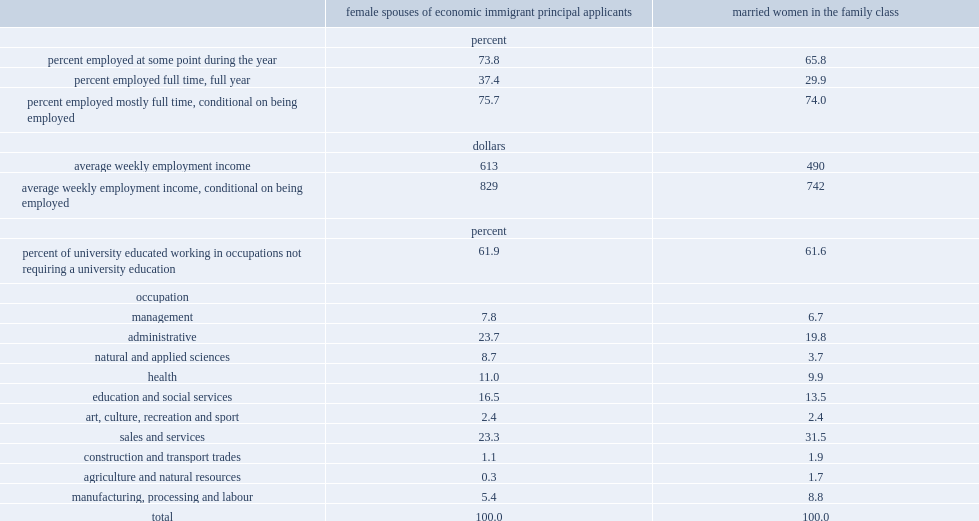Who worked at some point in 2010 more,married women who were economic immigrants or married women in the family class? Female spouses of economic immigrant principal applicants. What were the percentages of economic immigrant spouses and women in the family class who worked full time, full year in 2010 respectively? 37.4 29.9. What were the percentages of economic immigrant spouses and women in the family class who worked mostly full-time weeks respectively? 75.7 74.0. Who got higher weekly earnings, whether conditional on being employed or not,economic immigrant spouses or women in the family class? Female spouses of economic immigrant principal applicants. What was the percentage of married women in the family class woking in occupations in sales and services? 31.5. What were the percentages of economic immigrant spouses who worked in sales and services and natural and applied sciences respectively? 23.3 8.7. 